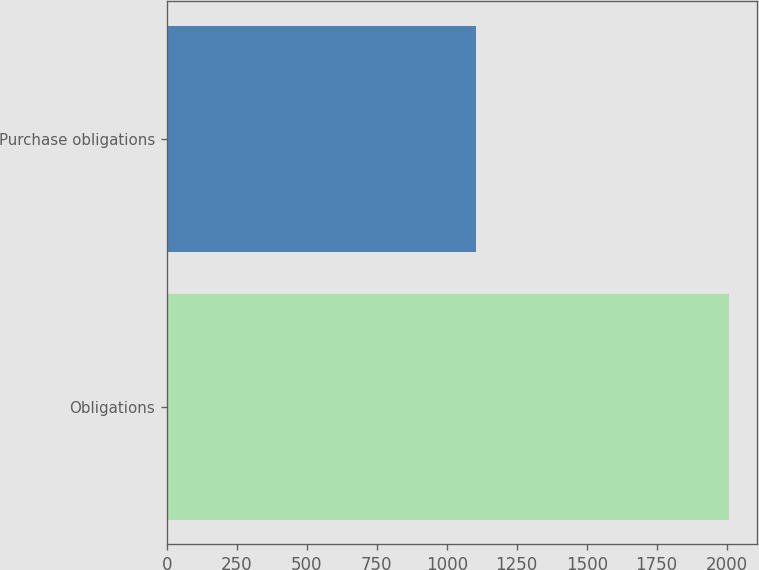Convert chart to OTSL. <chart><loc_0><loc_0><loc_500><loc_500><bar_chart><fcel>Obligations<fcel>Purchase obligations<nl><fcel>2009<fcel>1103.4<nl></chart> 